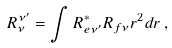Convert formula to latex. <formula><loc_0><loc_0><loc_500><loc_500>R _ { \nu } ^ { \nu ^ { \prime } } = \int R _ { e \nu ^ { \prime } } ^ { * } R _ { f \nu } r ^ { 2 } d r \, ,</formula> 